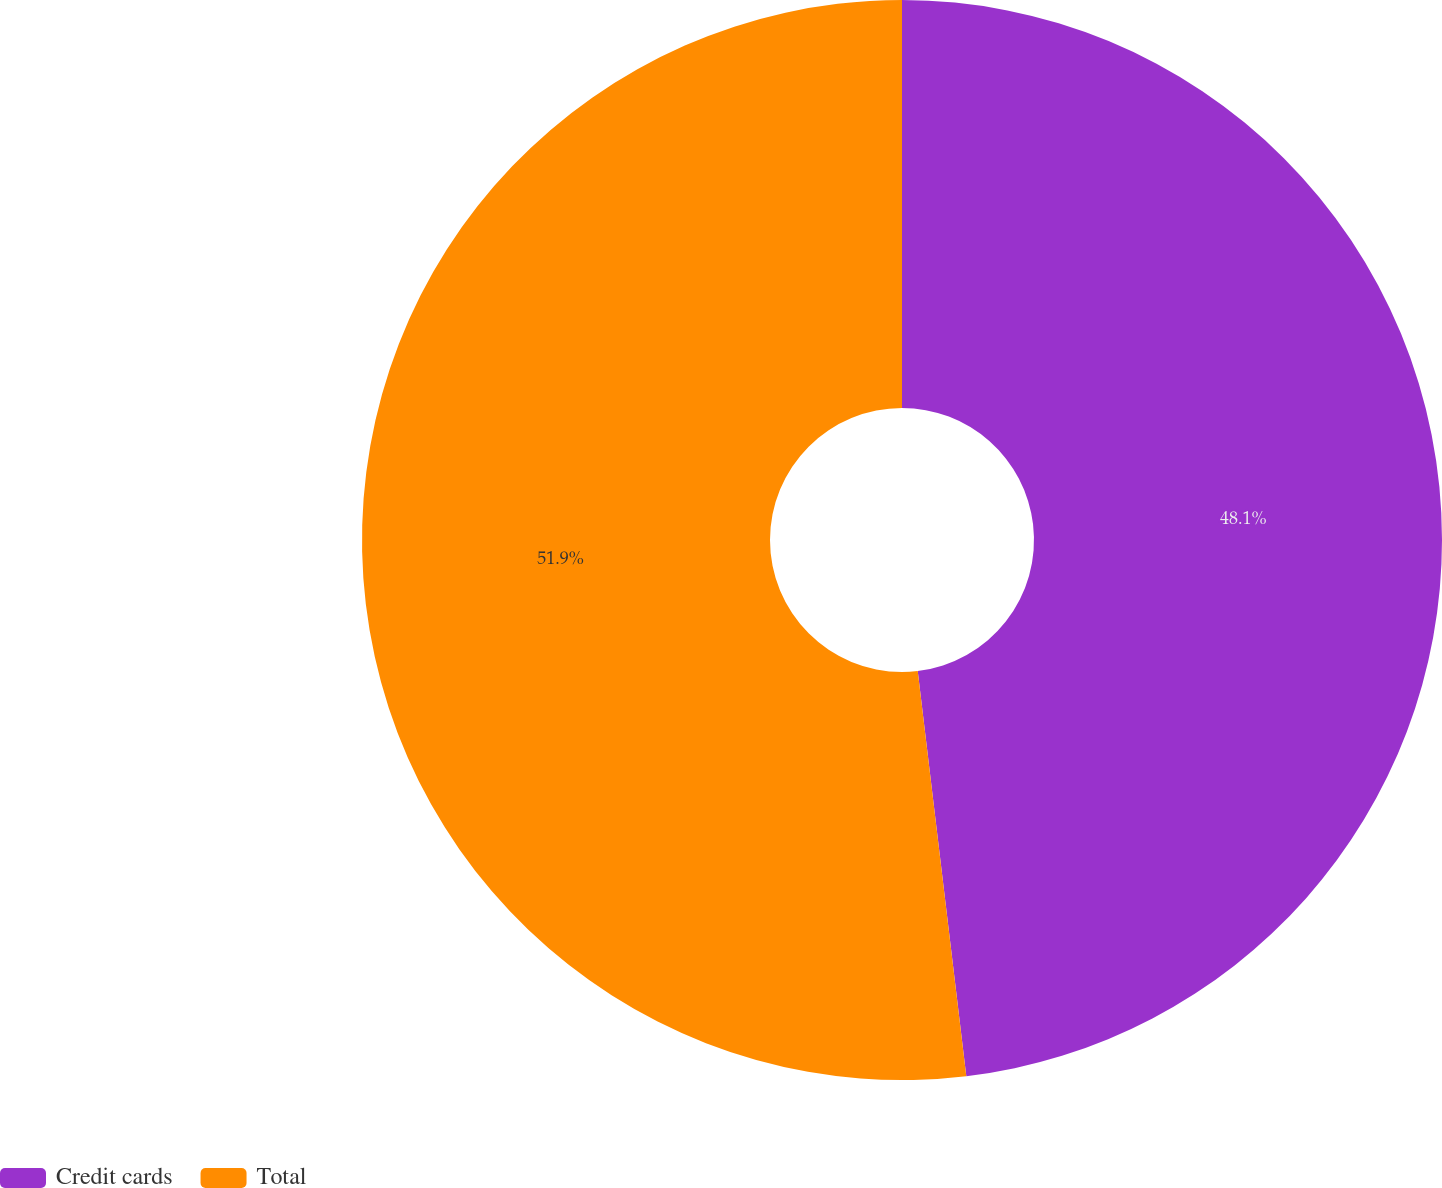Convert chart to OTSL. <chart><loc_0><loc_0><loc_500><loc_500><pie_chart><fcel>Credit cards<fcel>Total<nl><fcel>48.1%<fcel>51.9%<nl></chart> 